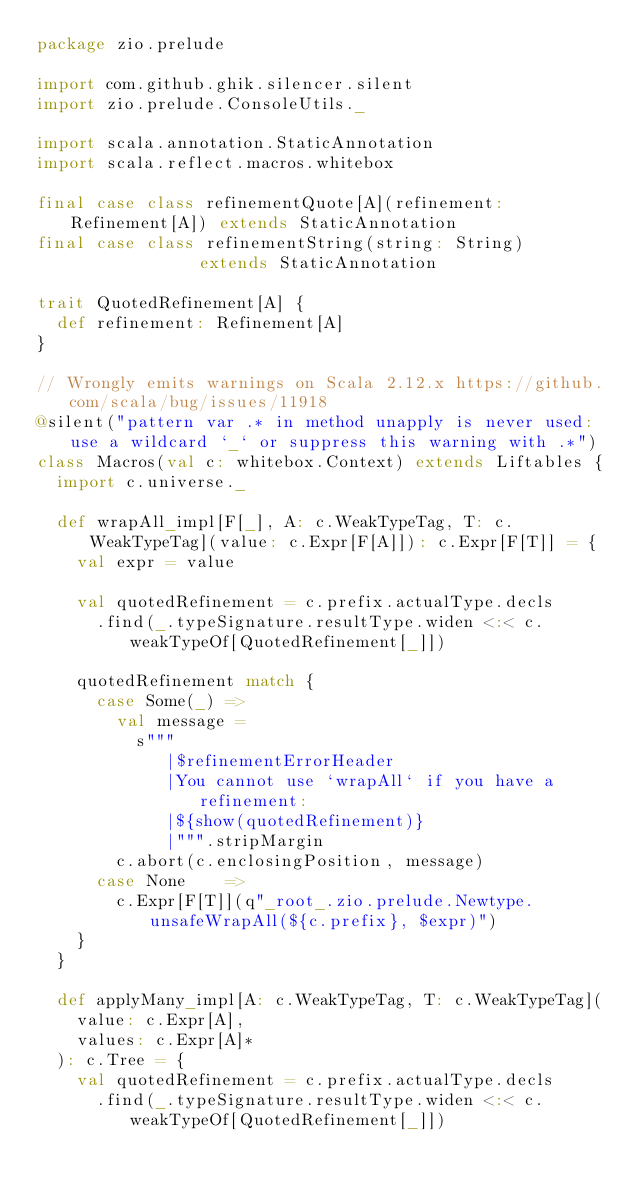Convert code to text. <code><loc_0><loc_0><loc_500><loc_500><_Scala_>package zio.prelude

import com.github.ghik.silencer.silent
import zio.prelude.ConsoleUtils._

import scala.annotation.StaticAnnotation
import scala.reflect.macros.whitebox

final case class refinementQuote[A](refinement: Refinement[A]) extends StaticAnnotation
final case class refinementString(string: String)              extends StaticAnnotation

trait QuotedRefinement[A] {
  def refinement: Refinement[A]
}

// Wrongly emits warnings on Scala 2.12.x https://github.com/scala/bug/issues/11918
@silent("pattern var .* in method unapply is never used: use a wildcard `_` or suppress this warning with .*")
class Macros(val c: whitebox.Context) extends Liftables {
  import c.universe._

  def wrapAll_impl[F[_], A: c.WeakTypeTag, T: c.WeakTypeTag](value: c.Expr[F[A]]): c.Expr[F[T]] = {
    val expr = value

    val quotedRefinement = c.prefix.actualType.decls
      .find(_.typeSignature.resultType.widen <:< c.weakTypeOf[QuotedRefinement[_]])

    quotedRefinement match {
      case Some(_) =>
        val message =
          s"""
             |$refinementErrorHeader
             |You cannot use `wrapAll` if you have a refinement:
             |${show(quotedRefinement)}
             |""".stripMargin
        c.abort(c.enclosingPosition, message)
      case None    =>
        c.Expr[F[T]](q"_root_.zio.prelude.Newtype.unsafeWrapAll(${c.prefix}, $expr)")
    }
  }

  def applyMany_impl[A: c.WeakTypeTag, T: c.WeakTypeTag](
    value: c.Expr[A],
    values: c.Expr[A]*
  ): c.Tree = {
    val quotedRefinement = c.prefix.actualType.decls
      .find(_.typeSignature.resultType.widen <:< c.weakTypeOf[QuotedRefinement[_]])
</code> 